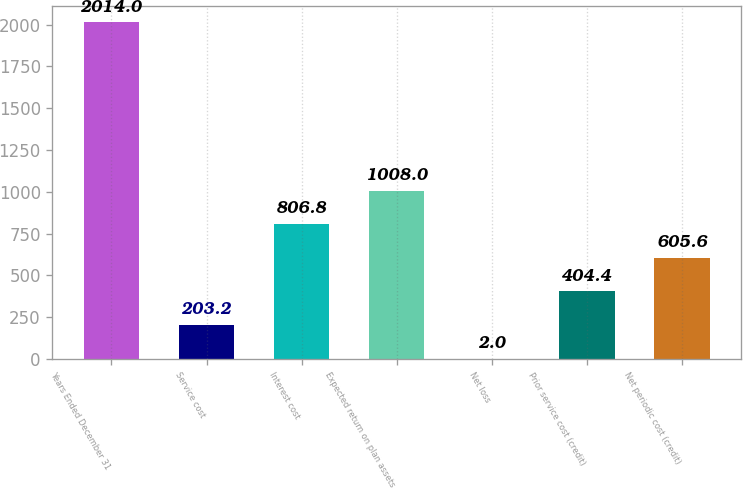Convert chart. <chart><loc_0><loc_0><loc_500><loc_500><bar_chart><fcel>Years Ended December 31<fcel>Service cost<fcel>Interest cost<fcel>Expected return on plan assets<fcel>Net loss<fcel>Prior service cost (credit)<fcel>Net periodic cost (credit)<nl><fcel>2014<fcel>203.2<fcel>806.8<fcel>1008<fcel>2<fcel>404.4<fcel>605.6<nl></chart> 